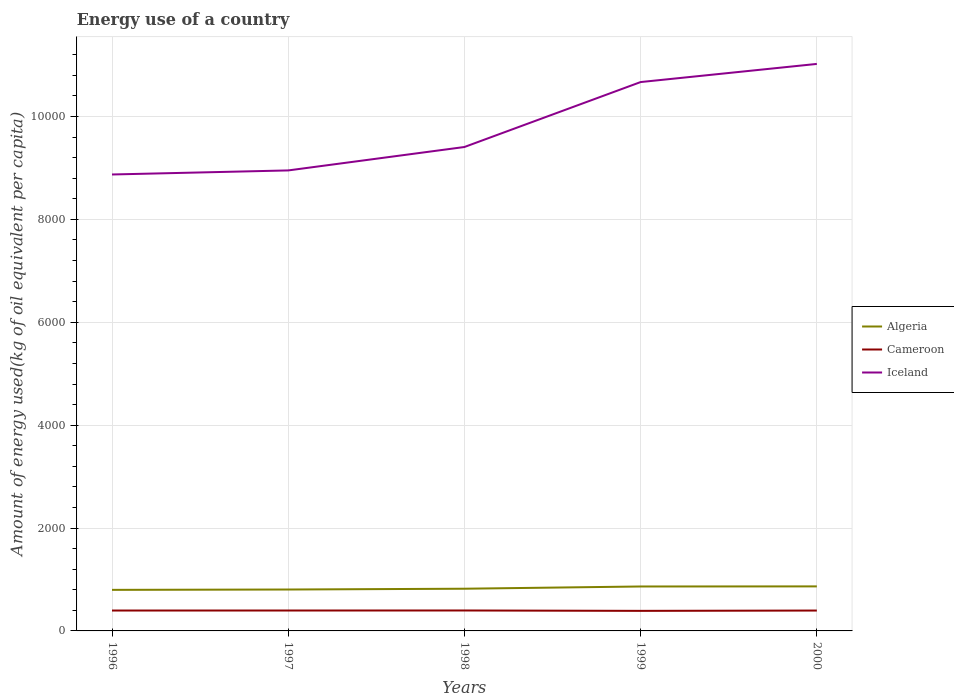How many different coloured lines are there?
Make the answer very short. 3. Does the line corresponding to Iceland intersect with the line corresponding to Algeria?
Make the answer very short. No. Is the number of lines equal to the number of legend labels?
Your answer should be compact. Yes. Across all years, what is the maximum amount of energy used in in Cameroon?
Your answer should be compact. 390.01. What is the total amount of energy used in in Iceland in the graph?
Ensure brevity in your answer.  -534.34. What is the difference between the highest and the second highest amount of energy used in in Cameroon?
Offer a very short reply. 7.39. Is the amount of energy used in in Algeria strictly greater than the amount of energy used in in Cameroon over the years?
Ensure brevity in your answer.  No. How many lines are there?
Give a very brief answer. 3. How many years are there in the graph?
Give a very brief answer. 5. What is the difference between two consecutive major ticks on the Y-axis?
Your answer should be very brief. 2000. Does the graph contain grids?
Provide a short and direct response. Yes. How are the legend labels stacked?
Provide a short and direct response. Vertical. What is the title of the graph?
Keep it short and to the point. Energy use of a country. What is the label or title of the X-axis?
Offer a terse response. Years. What is the label or title of the Y-axis?
Your answer should be compact. Amount of energy used(kg of oil equivalent per capita). What is the Amount of energy used(kg of oil equivalent per capita) in Algeria in 1996?
Keep it short and to the point. 798.23. What is the Amount of energy used(kg of oil equivalent per capita) of Cameroon in 1996?
Your answer should be compact. 396.33. What is the Amount of energy used(kg of oil equivalent per capita) in Iceland in 1996?
Your answer should be compact. 8873.66. What is the Amount of energy used(kg of oil equivalent per capita) in Algeria in 1997?
Offer a very short reply. 804.94. What is the Amount of energy used(kg of oil equivalent per capita) in Cameroon in 1997?
Give a very brief answer. 396.73. What is the Amount of energy used(kg of oil equivalent per capita) of Iceland in 1997?
Offer a terse response. 8952.65. What is the Amount of energy used(kg of oil equivalent per capita) in Algeria in 1998?
Offer a terse response. 820.38. What is the Amount of energy used(kg of oil equivalent per capita) of Cameroon in 1998?
Offer a terse response. 397.39. What is the Amount of energy used(kg of oil equivalent per capita) of Iceland in 1998?
Your response must be concise. 9408. What is the Amount of energy used(kg of oil equivalent per capita) of Algeria in 1999?
Provide a succinct answer. 863.79. What is the Amount of energy used(kg of oil equivalent per capita) of Cameroon in 1999?
Your answer should be very brief. 390.01. What is the Amount of energy used(kg of oil equivalent per capita) in Iceland in 1999?
Your answer should be compact. 1.07e+04. What is the Amount of energy used(kg of oil equivalent per capita) in Algeria in 2000?
Keep it short and to the point. 865.77. What is the Amount of energy used(kg of oil equivalent per capita) of Cameroon in 2000?
Provide a succinct answer. 396.14. What is the Amount of energy used(kg of oil equivalent per capita) of Iceland in 2000?
Provide a short and direct response. 1.10e+04. Across all years, what is the maximum Amount of energy used(kg of oil equivalent per capita) of Algeria?
Your response must be concise. 865.77. Across all years, what is the maximum Amount of energy used(kg of oil equivalent per capita) of Cameroon?
Provide a succinct answer. 397.39. Across all years, what is the maximum Amount of energy used(kg of oil equivalent per capita) in Iceland?
Offer a terse response. 1.10e+04. Across all years, what is the minimum Amount of energy used(kg of oil equivalent per capita) in Algeria?
Your answer should be compact. 798.23. Across all years, what is the minimum Amount of energy used(kg of oil equivalent per capita) in Cameroon?
Ensure brevity in your answer.  390.01. Across all years, what is the minimum Amount of energy used(kg of oil equivalent per capita) in Iceland?
Keep it short and to the point. 8873.66. What is the total Amount of energy used(kg of oil equivalent per capita) in Algeria in the graph?
Offer a terse response. 4153.1. What is the total Amount of energy used(kg of oil equivalent per capita) of Cameroon in the graph?
Your response must be concise. 1976.6. What is the total Amount of energy used(kg of oil equivalent per capita) in Iceland in the graph?
Your answer should be very brief. 4.89e+04. What is the difference between the Amount of energy used(kg of oil equivalent per capita) in Algeria in 1996 and that in 1997?
Offer a very short reply. -6.72. What is the difference between the Amount of energy used(kg of oil equivalent per capita) in Cameroon in 1996 and that in 1997?
Make the answer very short. -0.4. What is the difference between the Amount of energy used(kg of oil equivalent per capita) in Iceland in 1996 and that in 1997?
Give a very brief answer. -78.99. What is the difference between the Amount of energy used(kg of oil equivalent per capita) in Algeria in 1996 and that in 1998?
Ensure brevity in your answer.  -22.15. What is the difference between the Amount of energy used(kg of oil equivalent per capita) in Cameroon in 1996 and that in 1998?
Make the answer very short. -1.07. What is the difference between the Amount of energy used(kg of oil equivalent per capita) in Iceland in 1996 and that in 1998?
Make the answer very short. -534.34. What is the difference between the Amount of energy used(kg of oil equivalent per capita) in Algeria in 1996 and that in 1999?
Offer a very short reply. -65.56. What is the difference between the Amount of energy used(kg of oil equivalent per capita) in Cameroon in 1996 and that in 1999?
Offer a very short reply. 6.32. What is the difference between the Amount of energy used(kg of oil equivalent per capita) of Iceland in 1996 and that in 1999?
Offer a very short reply. -1796.88. What is the difference between the Amount of energy used(kg of oil equivalent per capita) of Algeria in 1996 and that in 2000?
Keep it short and to the point. -67.54. What is the difference between the Amount of energy used(kg of oil equivalent per capita) of Cameroon in 1996 and that in 2000?
Your response must be concise. 0.18. What is the difference between the Amount of energy used(kg of oil equivalent per capita) of Iceland in 1996 and that in 2000?
Make the answer very short. -2149.51. What is the difference between the Amount of energy used(kg of oil equivalent per capita) in Algeria in 1997 and that in 1998?
Provide a succinct answer. -15.44. What is the difference between the Amount of energy used(kg of oil equivalent per capita) in Iceland in 1997 and that in 1998?
Give a very brief answer. -455.35. What is the difference between the Amount of energy used(kg of oil equivalent per capita) in Algeria in 1997 and that in 1999?
Make the answer very short. -58.85. What is the difference between the Amount of energy used(kg of oil equivalent per capita) of Cameroon in 1997 and that in 1999?
Offer a terse response. 6.72. What is the difference between the Amount of energy used(kg of oil equivalent per capita) of Iceland in 1997 and that in 1999?
Make the answer very short. -1717.89. What is the difference between the Amount of energy used(kg of oil equivalent per capita) in Algeria in 1997 and that in 2000?
Your response must be concise. -60.83. What is the difference between the Amount of energy used(kg of oil equivalent per capita) of Cameroon in 1997 and that in 2000?
Provide a succinct answer. 0.58. What is the difference between the Amount of energy used(kg of oil equivalent per capita) of Iceland in 1997 and that in 2000?
Provide a short and direct response. -2070.51. What is the difference between the Amount of energy used(kg of oil equivalent per capita) in Algeria in 1998 and that in 1999?
Offer a terse response. -43.41. What is the difference between the Amount of energy used(kg of oil equivalent per capita) in Cameroon in 1998 and that in 1999?
Your answer should be compact. 7.39. What is the difference between the Amount of energy used(kg of oil equivalent per capita) in Iceland in 1998 and that in 1999?
Provide a short and direct response. -1262.54. What is the difference between the Amount of energy used(kg of oil equivalent per capita) of Algeria in 1998 and that in 2000?
Give a very brief answer. -45.39. What is the difference between the Amount of energy used(kg of oil equivalent per capita) in Cameroon in 1998 and that in 2000?
Provide a succinct answer. 1.25. What is the difference between the Amount of energy used(kg of oil equivalent per capita) of Iceland in 1998 and that in 2000?
Ensure brevity in your answer.  -1615.17. What is the difference between the Amount of energy used(kg of oil equivalent per capita) in Algeria in 1999 and that in 2000?
Your answer should be compact. -1.98. What is the difference between the Amount of energy used(kg of oil equivalent per capita) in Cameroon in 1999 and that in 2000?
Provide a short and direct response. -6.14. What is the difference between the Amount of energy used(kg of oil equivalent per capita) of Iceland in 1999 and that in 2000?
Offer a very short reply. -352.62. What is the difference between the Amount of energy used(kg of oil equivalent per capita) of Algeria in 1996 and the Amount of energy used(kg of oil equivalent per capita) of Cameroon in 1997?
Your answer should be compact. 401.5. What is the difference between the Amount of energy used(kg of oil equivalent per capita) of Algeria in 1996 and the Amount of energy used(kg of oil equivalent per capita) of Iceland in 1997?
Keep it short and to the point. -8154.42. What is the difference between the Amount of energy used(kg of oil equivalent per capita) in Cameroon in 1996 and the Amount of energy used(kg of oil equivalent per capita) in Iceland in 1997?
Keep it short and to the point. -8556.32. What is the difference between the Amount of energy used(kg of oil equivalent per capita) in Algeria in 1996 and the Amount of energy used(kg of oil equivalent per capita) in Cameroon in 1998?
Offer a terse response. 400.83. What is the difference between the Amount of energy used(kg of oil equivalent per capita) of Algeria in 1996 and the Amount of energy used(kg of oil equivalent per capita) of Iceland in 1998?
Make the answer very short. -8609.77. What is the difference between the Amount of energy used(kg of oil equivalent per capita) of Cameroon in 1996 and the Amount of energy used(kg of oil equivalent per capita) of Iceland in 1998?
Make the answer very short. -9011.67. What is the difference between the Amount of energy used(kg of oil equivalent per capita) of Algeria in 1996 and the Amount of energy used(kg of oil equivalent per capita) of Cameroon in 1999?
Your answer should be very brief. 408.22. What is the difference between the Amount of energy used(kg of oil equivalent per capita) of Algeria in 1996 and the Amount of energy used(kg of oil equivalent per capita) of Iceland in 1999?
Your answer should be very brief. -9872.31. What is the difference between the Amount of energy used(kg of oil equivalent per capita) of Cameroon in 1996 and the Amount of energy used(kg of oil equivalent per capita) of Iceland in 1999?
Provide a succinct answer. -1.03e+04. What is the difference between the Amount of energy used(kg of oil equivalent per capita) of Algeria in 1996 and the Amount of energy used(kg of oil equivalent per capita) of Cameroon in 2000?
Your answer should be very brief. 402.08. What is the difference between the Amount of energy used(kg of oil equivalent per capita) of Algeria in 1996 and the Amount of energy used(kg of oil equivalent per capita) of Iceland in 2000?
Keep it short and to the point. -1.02e+04. What is the difference between the Amount of energy used(kg of oil equivalent per capita) of Cameroon in 1996 and the Amount of energy used(kg of oil equivalent per capita) of Iceland in 2000?
Offer a terse response. -1.06e+04. What is the difference between the Amount of energy used(kg of oil equivalent per capita) in Algeria in 1997 and the Amount of energy used(kg of oil equivalent per capita) in Cameroon in 1998?
Keep it short and to the point. 407.55. What is the difference between the Amount of energy used(kg of oil equivalent per capita) in Algeria in 1997 and the Amount of energy used(kg of oil equivalent per capita) in Iceland in 1998?
Your response must be concise. -8603.06. What is the difference between the Amount of energy used(kg of oil equivalent per capita) of Cameroon in 1997 and the Amount of energy used(kg of oil equivalent per capita) of Iceland in 1998?
Ensure brevity in your answer.  -9011.27. What is the difference between the Amount of energy used(kg of oil equivalent per capita) in Algeria in 1997 and the Amount of energy used(kg of oil equivalent per capita) in Cameroon in 1999?
Your answer should be compact. 414.94. What is the difference between the Amount of energy used(kg of oil equivalent per capita) of Algeria in 1997 and the Amount of energy used(kg of oil equivalent per capita) of Iceland in 1999?
Give a very brief answer. -9865.6. What is the difference between the Amount of energy used(kg of oil equivalent per capita) in Cameroon in 1997 and the Amount of energy used(kg of oil equivalent per capita) in Iceland in 1999?
Offer a terse response. -1.03e+04. What is the difference between the Amount of energy used(kg of oil equivalent per capita) of Algeria in 1997 and the Amount of energy used(kg of oil equivalent per capita) of Cameroon in 2000?
Offer a terse response. 408.8. What is the difference between the Amount of energy used(kg of oil equivalent per capita) of Algeria in 1997 and the Amount of energy used(kg of oil equivalent per capita) of Iceland in 2000?
Provide a short and direct response. -1.02e+04. What is the difference between the Amount of energy used(kg of oil equivalent per capita) of Cameroon in 1997 and the Amount of energy used(kg of oil equivalent per capita) of Iceland in 2000?
Provide a succinct answer. -1.06e+04. What is the difference between the Amount of energy used(kg of oil equivalent per capita) in Algeria in 1998 and the Amount of energy used(kg of oil equivalent per capita) in Cameroon in 1999?
Make the answer very short. 430.37. What is the difference between the Amount of energy used(kg of oil equivalent per capita) in Algeria in 1998 and the Amount of energy used(kg of oil equivalent per capita) in Iceland in 1999?
Your answer should be compact. -9850.16. What is the difference between the Amount of energy used(kg of oil equivalent per capita) of Cameroon in 1998 and the Amount of energy used(kg of oil equivalent per capita) of Iceland in 1999?
Provide a succinct answer. -1.03e+04. What is the difference between the Amount of energy used(kg of oil equivalent per capita) in Algeria in 1998 and the Amount of energy used(kg of oil equivalent per capita) in Cameroon in 2000?
Make the answer very short. 424.23. What is the difference between the Amount of energy used(kg of oil equivalent per capita) of Algeria in 1998 and the Amount of energy used(kg of oil equivalent per capita) of Iceland in 2000?
Ensure brevity in your answer.  -1.02e+04. What is the difference between the Amount of energy used(kg of oil equivalent per capita) in Cameroon in 1998 and the Amount of energy used(kg of oil equivalent per capita) in Iceland in 2000?
Keep it short and to the point. -1.06e+04. What is the difference between the Amount of energy used(kg of oil equivalent per capita) in Algeria in 1999 and the Amount of energy used(kg of oil equivalent per capita) in Cameroon in 2000?
Ensure brevity in your answer.  467.65. What is the difference between the Amount of energy used(kg of oil equivalent per capita) of Algeria in 1999 and the Amount of energy used(kg of oil equivalent per capita) of Iceland in 2000?
Give a very brief answer. -1.02e+04. What is the difference between the Amount of energy used(kg of oil equivalent per capita) of Cameroon in 1999 and the Amount of energy used(kg of oil equivalent per capita) of Iceland in 2000?
Provide a succinct answer. -1.06e+04. What is the average Amount of energy used(kg of oil equivalent per capita) in Algeria per year?
Make the answer very short. 830.62. What is the average Amount of energy used(kg of oil equivalent per capita) in Cameroon per year?
Offer a very short reply. 395.32. What is the average Amount of energy used(kg of oil equivalent per capita) of Iceland per year?
Give a very brief answer. 9785.6. In the year 1996, what is the difference between the Amount of energy used(kg of oil equivalent per capita) of Algeria and Amount of energy used(kg of oil equivalent per capita) of Cameroon?
Your answer should be compact. 401.9. In the year 1996, what is the difference between the Amount of energy used(kg of oil equivalent per capita) in Algeria and Amount of energy used(kg of oil equivalent per capita) in Iceland?
Offer a terse response. -8075.43. In the year 1996, what is the difference between the Amount of energy used(kg of oil equivalent per capita) of Cameroon and Amount of energy used(kg of oil equivalent per capita) of Iceland?
Make the answer very short. -8477.33. In the year 1997, what is the difference between the Amount of energy used(kg of oil equivalent per capita) of Algeria and Amount of energy used(kg of oil equivalent per capita) of Cameroon?
Provide a succinct answer. 408.21. In the year 1997, what is the difference between the Amount of energy used(kg of oil equivalent per capita) of Algeria and Amount of energy used(kg of oil equivalent per capita) of Iceland?
Offer a terse response. -8147.71. In the year 1997, what is the difference between the Amount of energy used(kg of oil equivalent per capita) in Cameroon and Amount of energy used(kg of oil equivalent per capita) in Iceland?
Your response must be concise. -8555.92. In the year 1998, what is the difference between the Amount of energy used(kg of oil equivalent per capita) of Algeria and Amount of energy used(kg of oil equivalent per capita) of Cameroon?
Your response must be concise. 422.98. In the year 1998, what is the difference between the Amount of energy used(kg of oil equivalent per capita) of Algeria and Amount of energy used(kg of oil equivalent per capita) of Iceland?
Offer a very short reply. -8587.62. In the year 1998, what is the difference between the Amount of energy used(kg of oil equivalent per capita) of Cameroon and Amount of energy used(kg of oil equivalent per capita) of Iceland?
Your answer should be compact. -9010.61. In the year 1999, what is the difference between the Amount of energy used(kg of oil equivalent per capita) of Algeria and Amount of energy used(kg of oil equivalent per capita) of Cameroon?
Your response must be concise. 473.78. In the year 1999, what is the difference between the Amount of energy used(kg of oil equivalent per capita) in Algeria and Amount of energy used(kg of oil equivalent per capita) in Iceland?
Give a very brief answer. -9806.75. In the year 1999, what is the difference between the Amount of energy used(kg of oil equivalent per capita) of Cameroon and Amount of energy used(kg of oil equivalent per capita) of Iceland?
Your answer should be compact. -1.03e+04. In the year 2000, what is the difference between the Amount of energy used(kg of oil equivalent per capita) in Algeria and Amount of energy used(kg of oil equivalent per capita) in Cameroon?
Provide a succinct answer. 469.63. In the year 2000, what is the difference between the Amount of energy used(kg of oil equivalent per capita) of Algeria and Amount of energy used(kg of oil equivalent per capita) of Iceland?
Provide a short and direct response. -1.02e+04. In the year 2000, what is the difference between the Amount of energy used(kg of oil equivalent per capita) in Cameroon and Amount of energy used(kg of oil equivalent per capita) in Iceland?
Provide a succinct answer. -1.06e+04. What is the ratio of the Amount of energy used(kg of oil equivalent per capita) of Cameroon in 1996 to that in 1997?
Offer a very short reply. 1. What is the ratio of the Amount of energy used(kg of oil equivalent per capita) of Algeria in 1996 to that in 1998?
Make the answer very short. 0.97. What is the ratio of the Amount of energy used(kg of oil equivalent per capita) in Iceland in 1996 to that in 1998?
Provide a short and direct response. 0.94. What is the ratio of the Amount of energy used(kg of oil equivalent per capita) of Algeria in 1996 to that in 1999?
Ensure brevity in your answer.  0.92. What is the ratio of the Amount of energy used(kg of oil equivalent per capita) of Cameroon in 1996 to that in 1999?
Keep it short and to the point. 1.02. What is the ratio of the Amount of energy used(kg of oil equivalent per capita) in Iceland in 1996 to that in 1999?
Ensure brevity in your answer.  0.83. What is the ratio of the Amount of energy used(kg of oil equivalent per capita) of Algeria in 1996 to that in 2000?
Keep it short and to the point. 0.92. What is the ratio of the Amount of energy used(kg of oil equivalent per capita) in Cameroon in 1996 to that in 2000?
Offer a terse response. 1. What is the ratio of the Amount of energy used(kg of oil equivalent per capita) of Iceland in 1996 to that in 2000?
Your answer should be compact. 0.81. What is the ratio of the Amount of energy used(kg of oil equivalent per capita) in Algeria in 1997 to that in 1998?
Your answer should be compact. 0.98. What is the ratio of the Amount of energy used(kg of oil equivalent per capita) in Cameroon in 1997 to that in 1998?
Keep it short and to the point. 1. What is the ratio of the Amount of energy used(kg of oil equivalent per capita) of Iceland in 1997 to that in 1998?
Give a very brief answer. 0.95. What is the ratio of the Amount of energy used(kg of oil equivalent per capita) of Algeria in 1997 to that in 1999?
Keep it short and to the point. 0.93. What is the ratio of the Amount of energy used(kg of oil equivalent per capita) in Cameroon in 1997 to that in 1999?
Give a very brief answer. 1.02. What is the ratio of the Amount of energy used(kg of oil equivalent per capita) of Iceland in 1997 to that in 1999?
Give a very brief answer. 0.84. What is the ratio of the Amount of energy used(kg of oil equivalent per capita) of Algeria in 1997 to that in 2000?
Provide a short and direct response. 0.93. What is the ratio of the Amount of energy used(kg of oil equivalent per capita) in Cameroon in 1997 to that in 2000?
Make the answer very short. 1. What is the ratio of the Amount of energy used(kg of oil equivalent per capita) of Iceland in 1997 to that in 2000?
Give a very brief answer. 0.81. What is the ratio of the Amount of energy used(kg of oil equivalent per capita) in Algeria in 1998 to that in 1999?
Provide a succinct answer. 0.95. What is the ratio of the Amount of energy used(kg of oil equivalent per capita) of Cameroon in 1998 to that in 1999?
Keep it short and to the point. 1.02. What is the ratio of the Amount of energy used(kg of oil equivalent per capita) in Iceland in 1998 to that in 1999?
Give a very brief answer. 0.88. What is the ratio of the Amount of energy used(kg of oil equivalent per capita) in Algeria in 1998 to that in 2000?
Ensure brevity in your answer.  0.95. What is the ratio of the Amount of energy used(kg of oil equivalent per capita) in Iceland in 1998 to that in 2000?
Offer a very short reply. 0.85. What is the ratio of the Amount of energy used(kg of oil equivalent per capita) of Algeria in 1999 to that in 2000?
Provide a short and direct response. 1. What is the ratio of the Amount of energy used(kg of oil equivalent per capita) of Cameroon in 1999 to that in 2000?
Offer a terse response. 0.98. What is the ratio of the Amount of energy used(kg of oil equivalent per capita) in Iceland in 1999 to that in 2000?
Offer a very short reply. 0.97. What is the difference between the highest and the second highest Amount of energy used(kg of oil equivalent per capita) of Algeria?
Give a very brief answer. 1.98. What is the difference between the highest and the second highest Amount of energy used(kg of oil equivalent per capita) in Iceland?
Give a very brief answer. 352.62. What is the difference between the highest and the lowest Amount of energy used(kg of oil equivalent per capita) in Algeria?
Provide a succinct answer. 67.54. What is the difference between the highest and the lowest Amount of energy used(kg of oil equivalent per capita) of Cameroon?
Offer a very short reply. 7.39. What is the difference between the highest and the lowest Amount of energy used(kg of oil equivalent per capita) in Iceland?
Your response must be concise. 2149.51. 